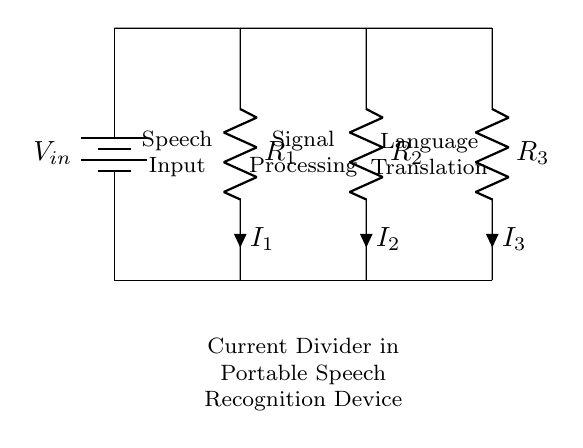What are the values of the resistors in the circuit? The circuit diagram indicates resistors R1, R2, and R3, but the specific values are not provided visually.
Answer: Not provided What is the purpose of the current divider in this device? A current divider helps distribute input current among various parallel paths (resistors) in the circuit, which is essential for balancing the load and achieving desired operational parameters within the speech recognition device.
Answer: Distributing current How many resistors are present in the circuit? The circuit diagram shows three resistors (R1, R2, R3) connected in parallel.
Answer: Three What does the voltage source represent in this circuit? The voltage source represents the input voltage (Vin) that powers the entire circuit, providing the necessary potential difference for current to flow through the resistors.
Answer: Input voltage Which component does not consume power in the circuit? The short connections depicted in the circuit do not consume power as they merely facilitate the flow of current without resistance.
Answer: Shorts How does the total current relate to branch currents in this current divider? The total current entering the circuit is equal to the sum of the currents through each branch (I1, I2, I3), adhering to the principle of current conservation in parallel circuits: I_total = I1 + I2 + I3.
Answer: I_total = I1 + I2 + I3 